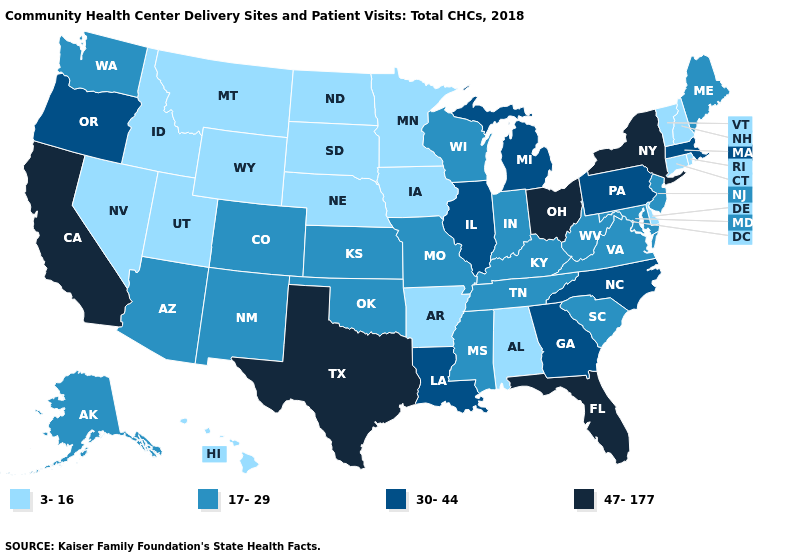How many symbols are there in the legend?
Short answer required. 4. Name the states that have a value in the range 30-44?
Short answer required. Georgia, Illinois, Louisiana, Massachusetts, Michigan, North Carolina, Oregon, Pennsylvania. Does the map have missing data?
Give a very brief answer. No. Name the states that have a value in the range 30-44?
Write a very short answer. Georgia, Illinois, Louisiana, Massachusetts, Michigan, North Carolina, Oregon, Pennsylvania. Which states have the lowest value in the USA?
Short answer required. Alabama, Arkansas, Connecticut, Delaware, Hawaii, Idaho, Iowa, Minnesota, Montana, Nebraska, Nevada, New Hampshire, North Dakota, Rhode Island, South Dakota, Utah, Vermont, Wyoming. Name the states that have a value in the range 47-177?
Keep it brief. California, Florida, New York, Ohio, Texas. Which states have the lowest value in the USA?
Quick response, please. Alabama, Arkansas, Connecticut, Delaware, Hawaii, Idaho, Iowa, Minnesota, Montana, Nebraska, Nevada, New Hampshire, North Dakota, Rhode Island, South Dakota, Utah, Vermont, Wyoming. Does Virginia have the lowest value in the South?
Quick response, please. No. Does Montana have the lowest value in the West?
Be succinct. Yes. What is the lowest value in the USA?
Write a very short answer. 3-16. Does Iowa have the highest value in the MidWest?
Write a very short answer. No. Which states have the highest value in the USA?
Quick response, please. California, Florida, New York, Ohio, Texas. How many symbols are there in the legend?
Keep it brief. 4. What is the value of Rhode Island?
Answer briefly. 3-16. Among the states that border Delaware , does Pennsylvania have the highest value?
Short answer required. Yes. 